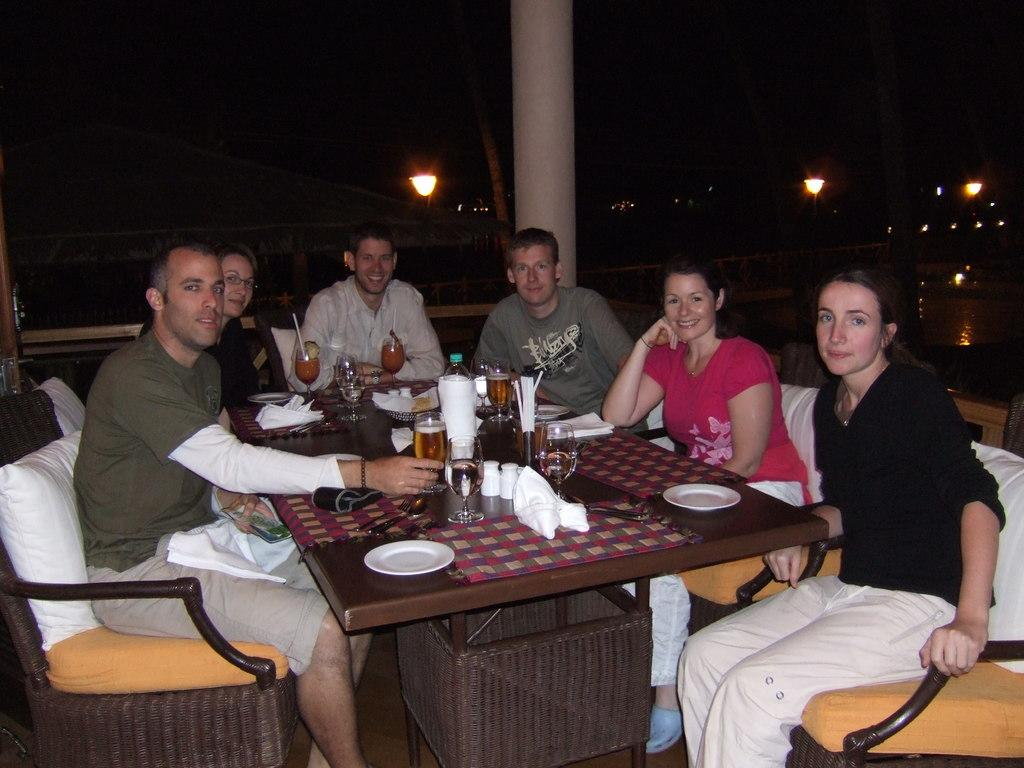How many people are in the image? There is a group of people in the image. What are the people doing in the image? The people are sitting in chairs. Where are the chairs located in relation to the table? The chairs are near a table. What items can be seen on the table? There is a plate, tissue, a glass, and a bottle on the table. What can be seen in the background of the image? There is a light and a pole in the background of the image. What type of board is being used by the people in the image? There is no board present in the image; the people are sitting in chairs near a table. Can you see any robins in the image? There are no robins present in the image. 